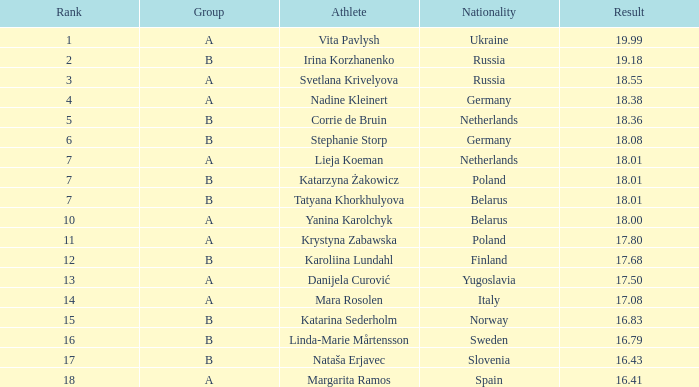What is the average rank for Group A athlete Yanina Karolchyk, and a result higher than 18? None. 